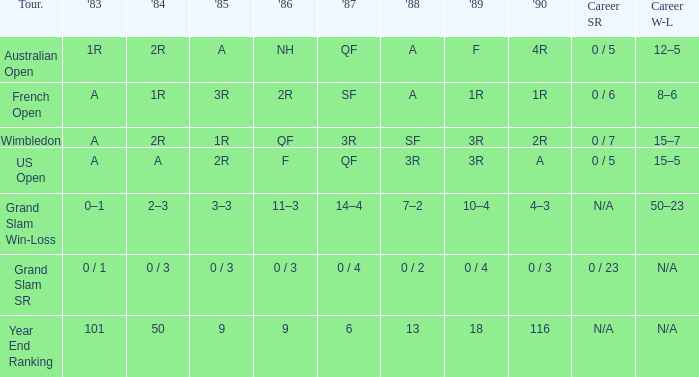With a 1986 of nh and a career sr of 0 / 5, what were the findings in 1985? A. 